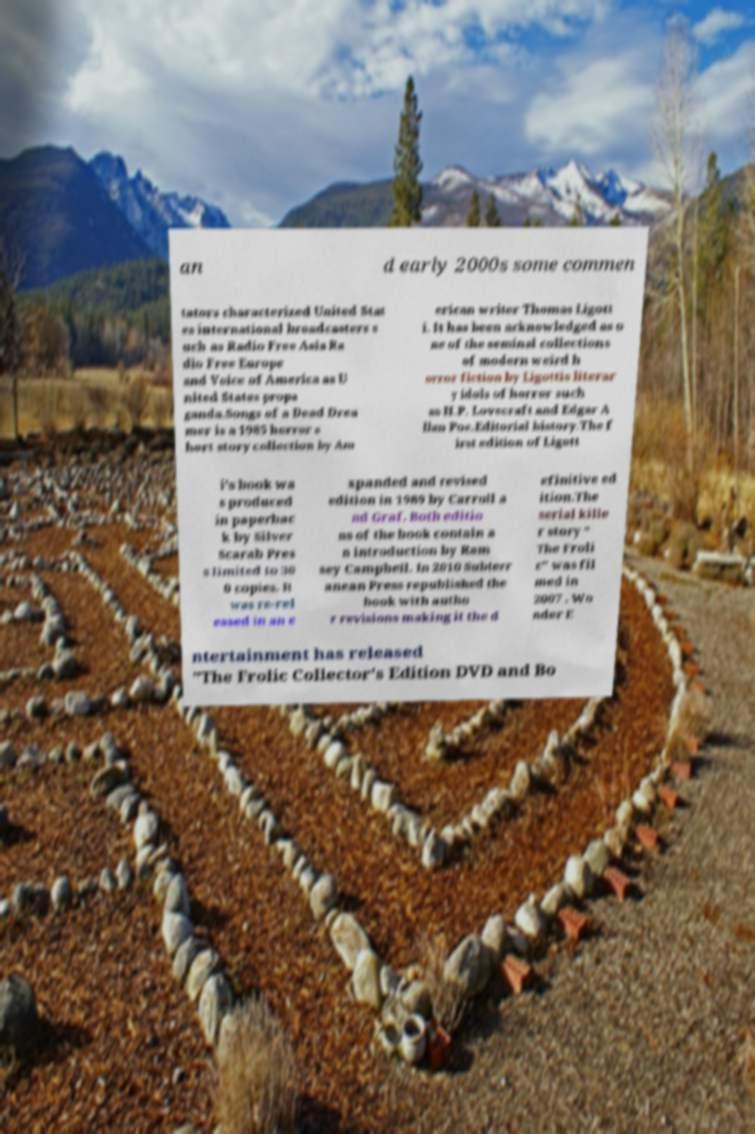Could you assist in decoding the text presented in this image and type it out clearly? an d early 2000s some commen tators characterized United Stat es international broadcasters s uch as Radio Free Asia Ra dio Free Europe and Voice of America as U nited States propa ganda.Songs of a Dead Drea mer is a 1985 horror s hort story collection by Am erican writer Thomas Ligott i. It has been acknowledged as o ne of the seminal collections of modern weird h orror fiction by Ligottis literar y idols of horror such as H.P. Lovecraft and Edgar A llan Poe.Editorial history.The f irst edition of Ligott i's book wa s produced in paperbac k by Silver Scarab Pres s limited to 30 0 copies. It was re-rel eased in an e xpanded and revised edition in 1989 by Carroll a nd Graf. Both editio ns of the book contain a n introduction by Ram sey Campbell. In 2010 Subterr anean Press republished the book with autho r revisions making it the d efinitive ed ition.The serial kille r story " The Froli c" was fil med in 2007 . Wo nder E ntertainment has released "The Frolic Collector's Edition DVD and Bo 